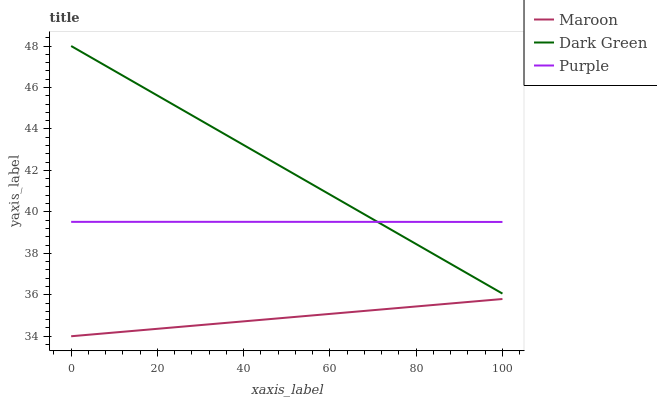Does Dark Green have the minimum area under the curve?
Answer yes or no. No. Does Maroon have the maximum area under the curve?
Answer yes or no. No. Is Dark Green the smoothest?
Answer yes or no. No. Is Dark Green the roughest?
Answer yes or no. No. Does Dark Green have the lowest value?
Answer yes or no. No. Does Maroon have the highest value?
Answer yes or no. No. Is Maroon less than Purple?
Answer yes or no. Yes. Is Purple greater than Maroon?
Answer yes or no. Yes. Does Maroon intersect Purple?
Answer yes or no. No. 